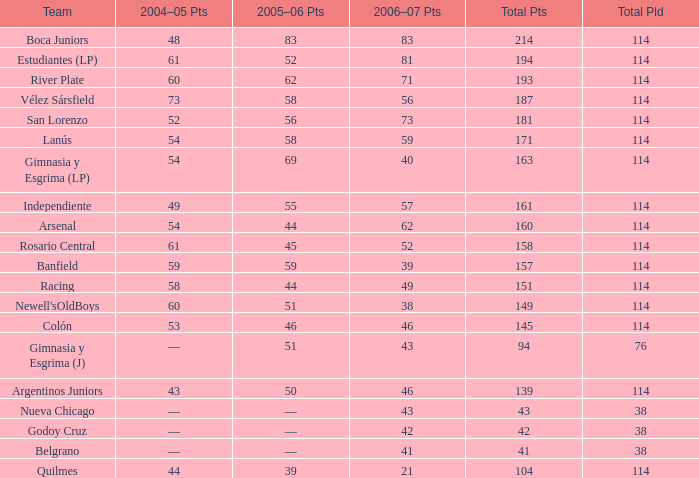What is the overall pld with 158 points in 2006-07, and below 52 points in 2006-07? None. 